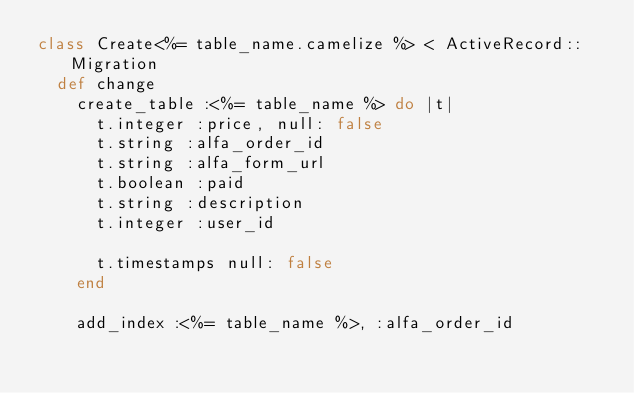Convert code to text. <code><loc_0><loc_0><loc_500><loc_500><_Ruby_>class Create<%= table_name.camelize %> < ActiveRecord::Migration
  def change
    create_table :<%= table_name %> do |t|
      t.integer :price, null: false
      t.string :alfa_order_id
      t.string :alfa_form_url
      t.boolean :paid
      t.string :description
      t.integer :user_id

      t.timestamps null: false
    end

    add_index :<%= table_name %>, :alfa_order_id</code> 